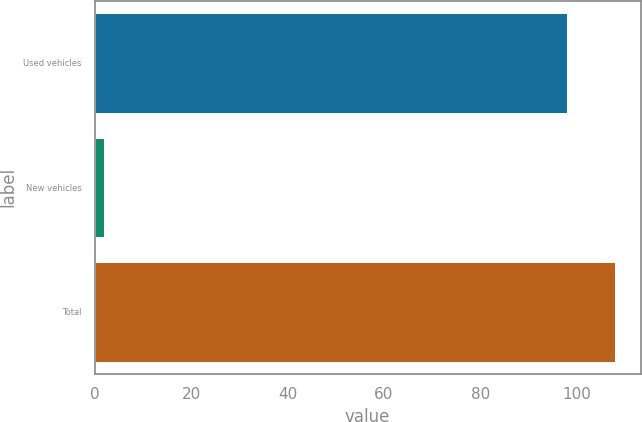<chart> <loc_0><loc_0><loc_500><loc_500><bar_chart><fcel>Used vehicles<fcel>New vehicles<fcel>Total<nl><fcel>98<fcel>2<fcel>107.8<nl></chart> 